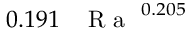<formula> <loc_0><loc_0><loc_500><loc_500>0 . 1 9 1 \, { R a } ^ { 0 . 2 0 5 }</formula> 